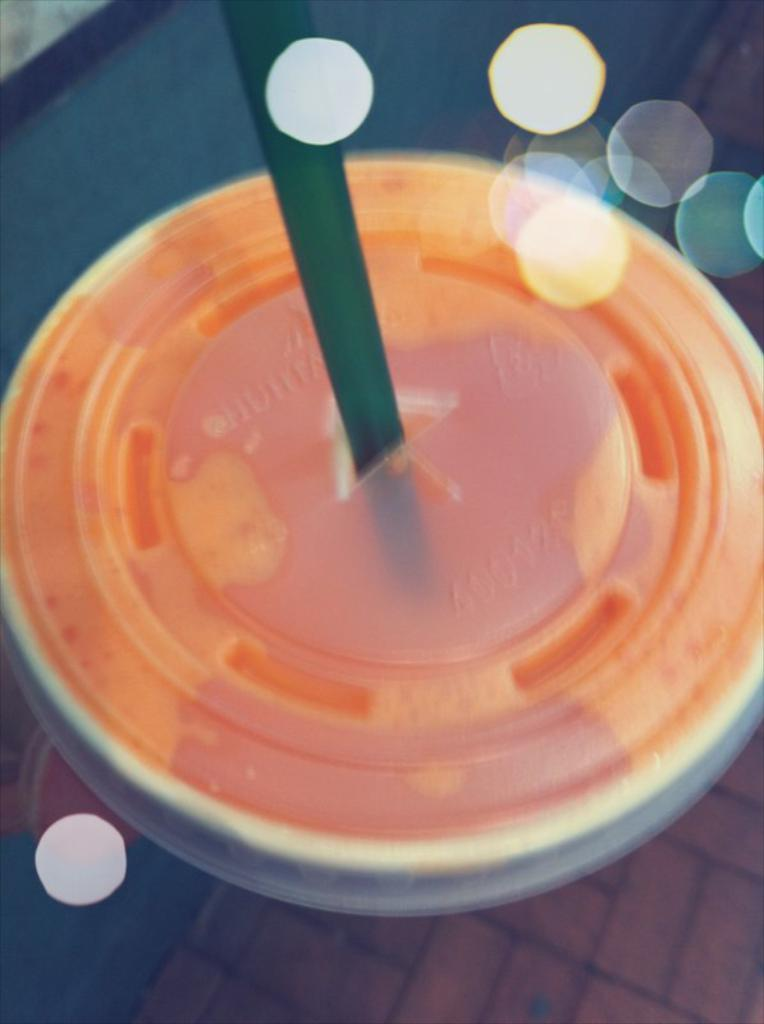What is in the image that can hold liquid? There is a cup in the image that can hold liquid. What feature does the cup have to prevent spills? The cup has a lid. What is inside the cup? There is liquid in the cup. How can someone drink the liquid from the cup? There is a straw in the cup. What type of beam is supporting the cup in the image? There is no beam present in the image; the cup is likely resting on a surface. 